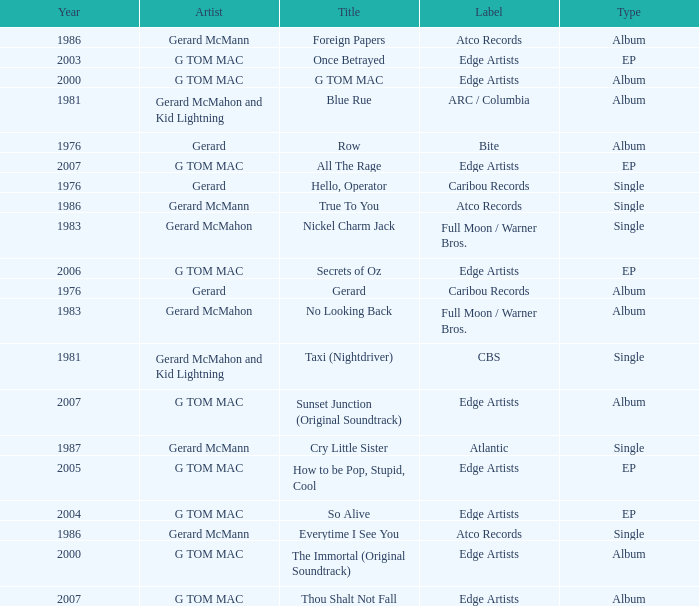Which Title has a Type of album in 1983? No Looking Back. 